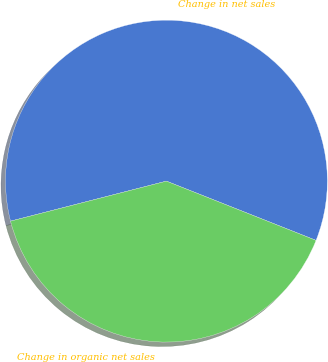<chart> <loc_0><loc_0><loc_500><loc_500><pie_chart><fcel>Change in net sales<fcel>Change in organic net sales<nl><fcel>60.0%<fcel>40.0%<nl></chart> 